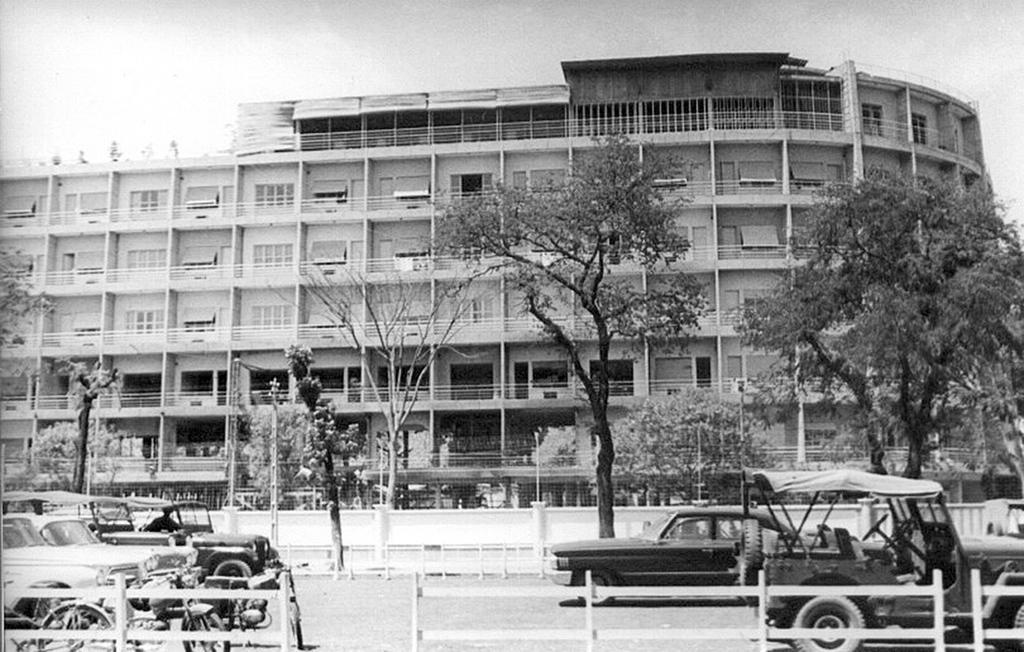In one or two sentences, can you explain what this image depicts? This is a black and white picture. Here we can see 3 cars and 3 beeps and one motorcycle. Here we have a 5 storey building and before the building we have few trees planted and these cars are parked in a fenced area. 